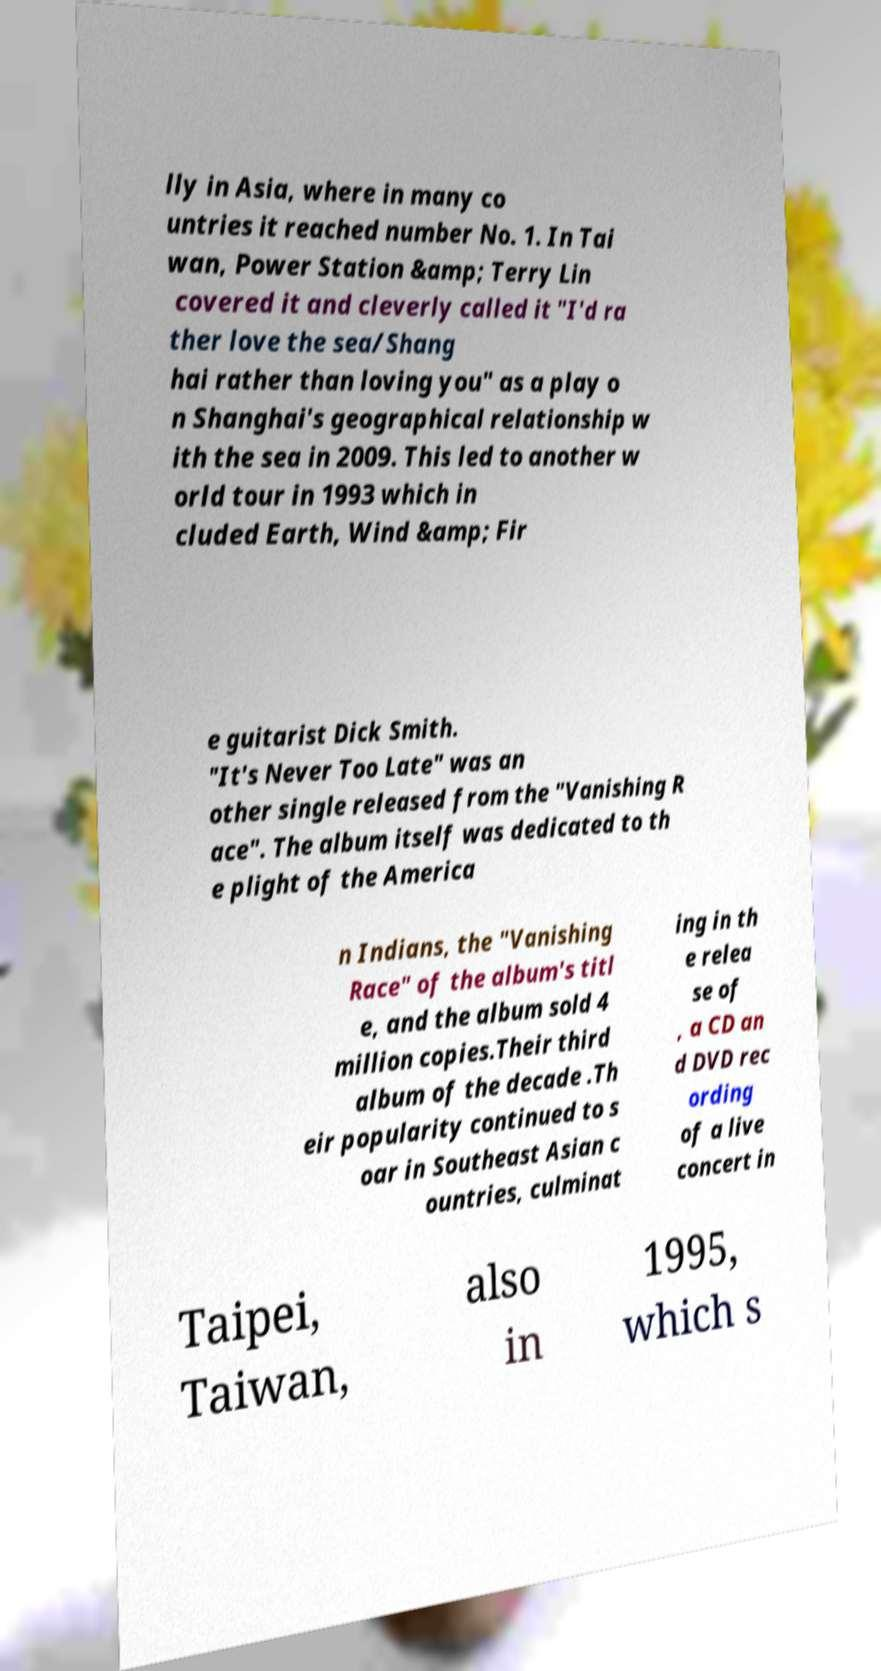What messages or text are displayed in this image? I need them in a readable, typed format. lly in Asia, where in many co untries it reached number No. 1. In Tai wan, Power Station &amp; Terry Lin covered it and cleverly called it "I'd ra ther love the sea/Shang hai rather than loving you" as a play o n Shanghai's geographical relationship w ith the sea in 2009. This led to another w orld tour in 1993 which in cluded Earth, Wind &amp; Fir e guitarist Dick Smith. "It's Never Too Late" was an other single released from the "Vanishing R ace". The album itself was dedicated to th e plight of the America n Indians, the "Vanishing Race" of the album's titl e, and the album sold 4 million copies.Their third album of the decade .Th eir popularity continued to s oar in Southeast Asian c ountries, culminat ing in th e relea se of , a CD an d DVD rec ording of a live concert in Taipei, Taiwan, also in 1995, which s 